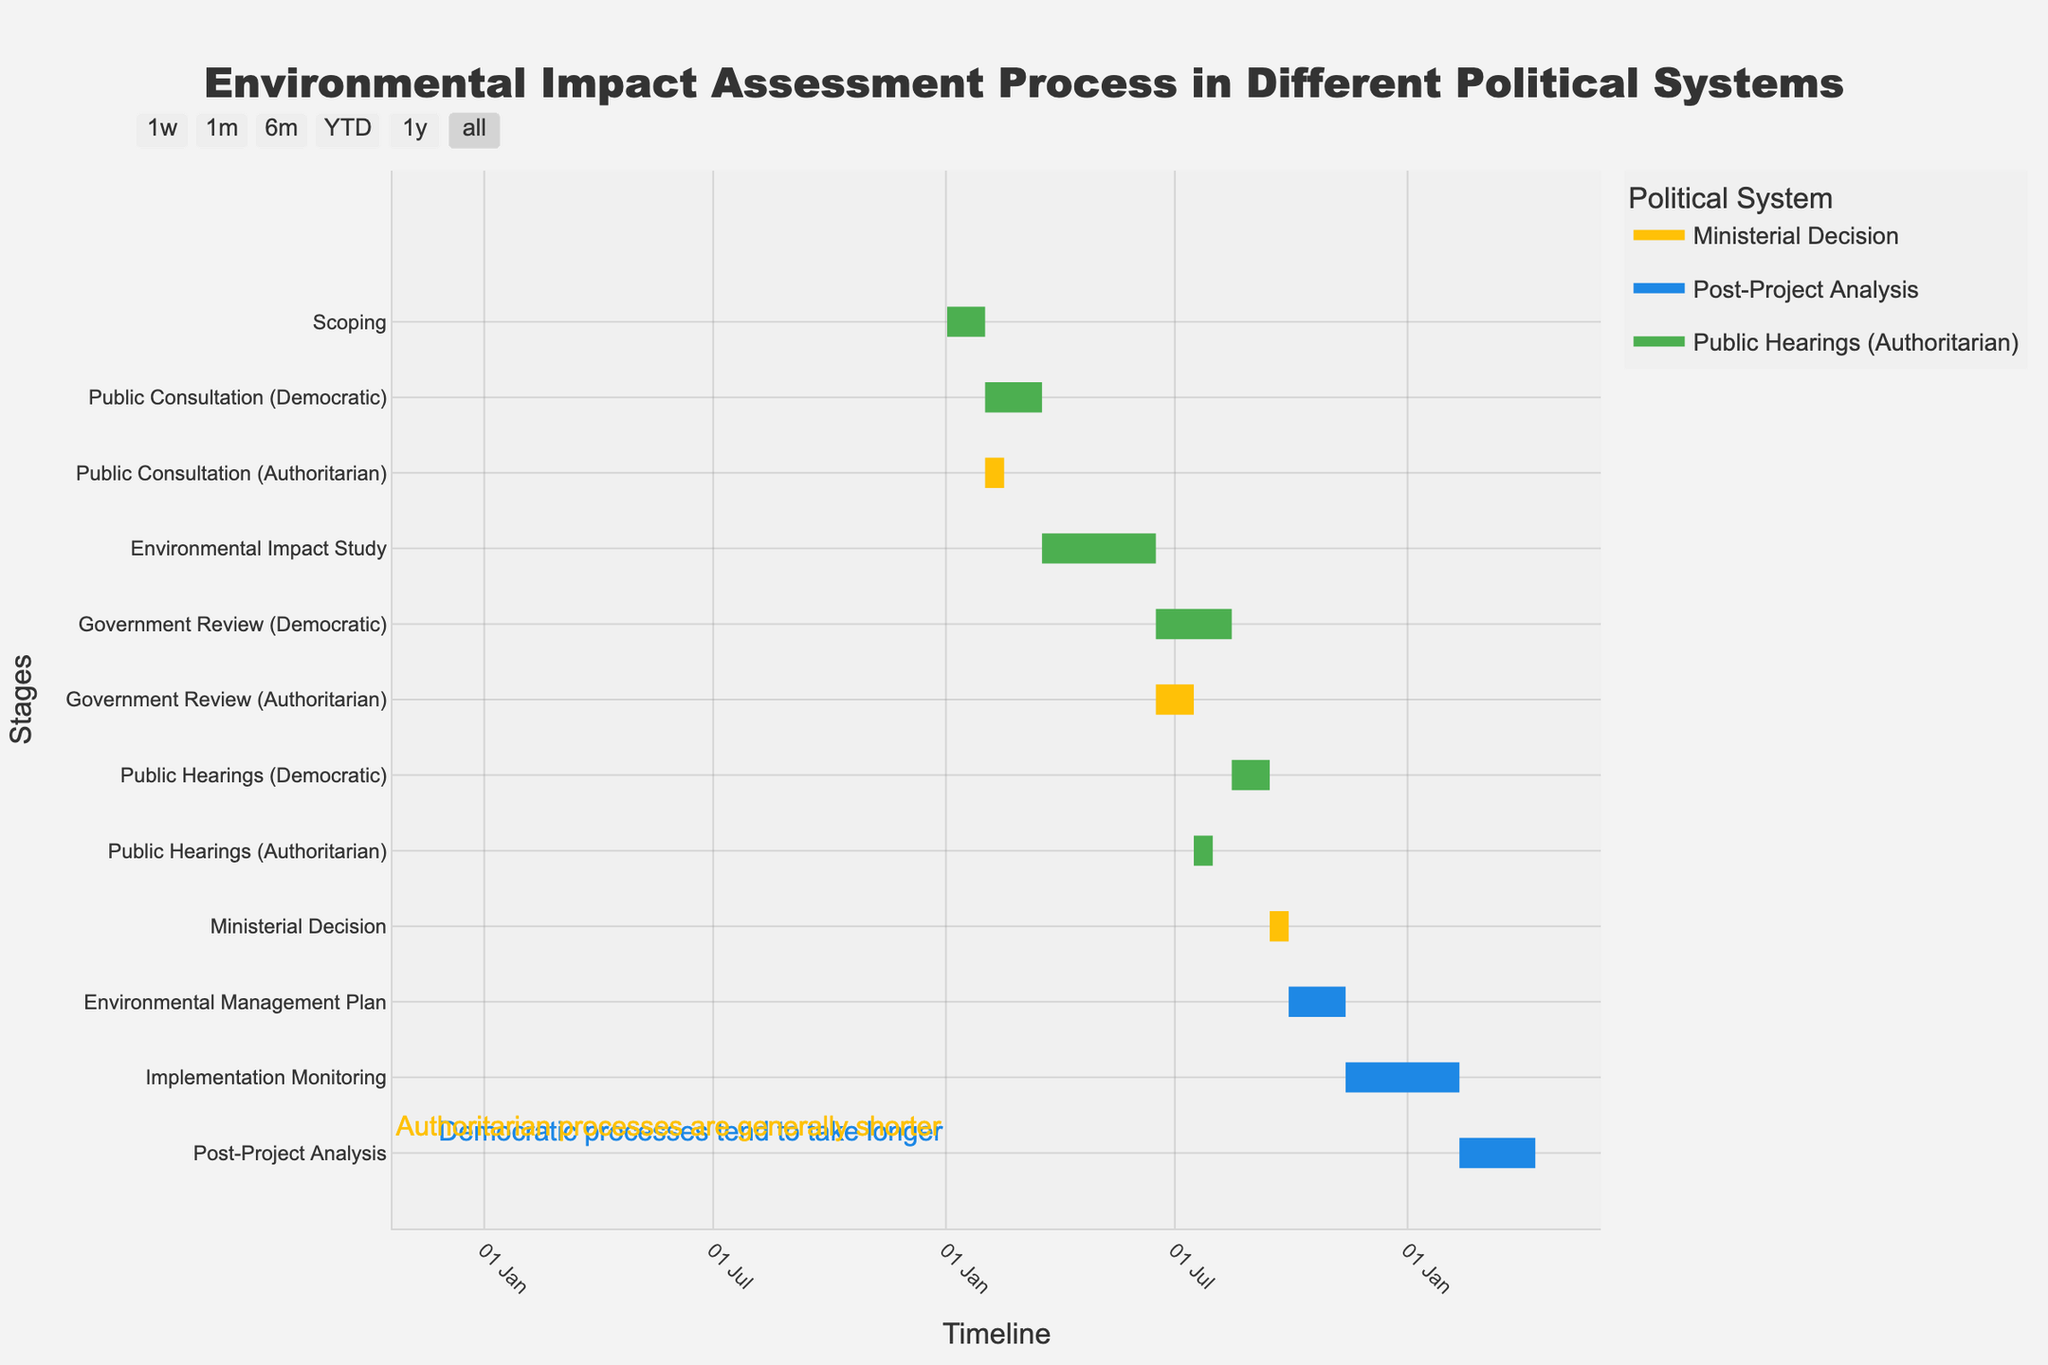What is the title of the Gantt chart? The title of the Gantt chart is displayed at the top of the visual. It reads "Environmental Impact Assessment Process in Different Political Systems".
Answer: Environmental Impact Assessment Process in Different Political Systems How many stages last 30 days in the Democratic system? By examining the color-coded stages, the Democratic system stages are in blue. Counting these stages, we find "Scoping" (30 days), "Government Review (Democratic)" (60 days but consider the starting day), and "Public Hearings (Democratic)" (30 days). Therefore, there is only one 30-day stage.
Answer: One stage Which stage starts immediately after the public consultation in the Authoritarian system? Reviewing the Gantt chart, the Public Consultation (Authoritarian) stage ends on day 45. The next stage, "Environmental Impact Study," starts on day 76, after a gap, meaning no stage starts immediately after.
Answer: None How much longer does Public Consultation last in Democratic systems compared to Authoritarian systems? By analyzing the duration of Public Consultations: Democratic system lasts 45 days and Authoritarian system lasts 15 days. The difference is 45 - 15.
Answer: 30 days What is the difference in duration between Government Review stages in Democratic and Authoritarian systems? The Government Review (Democratic) lasts 60 days, while the Government Review (Authoritarian) lasts 30 days. The difference is 60 - 30.
Answer: 30 days When does the Implementation Monitoring stage begin? The Implementation Monitoring stage begins after the Environmental Management Plan stage, which ends on day 316. Thus, Implementation Monitoring starts on day 316.
Answer: Day 316 Which stage has the shortest duration? By comparing the duration of all stages, the "Ministerial Decision" stage has the shortest duration of 15 days.
Answer: Ministerial Decision What is the combined duration of Public Hearings in both political systems? Adding the duration of Public Hearings in Democratic (30 days) and Authoritarian (15 days) systems: 30 + 15 equals 45 days.
Answer: 45 days Which stage(s) involve both political systems equally? The "Scoping," "Environmental Impact Study," "Environmental Management Plan," "Implementation Monitoring," and "Post-Project Analysis" stages do not specify political systems, thus involving both equally.
Answer: Scoping, Environmental Impact Study, Environmental Management Plan, Implementation Monitoring, Post-Project Analysis 